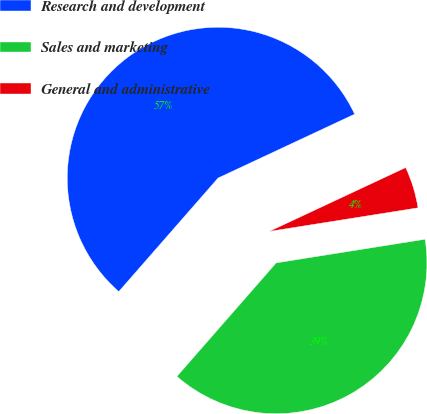Convert chart. <chart><loc_0><loc_0><loc_500><loc_500><pie_chart><fcel>Research and development<fcel>Sales and marketing<fcel>General and administrative<nl><fcel>56.6%<fcel>38.94%<fcel>4.46%<nl></chart> 